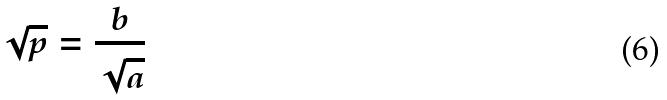<formula> <loc_0><loc_0><loc_500><loc_500>\sqrt { p } = \frac { b } { \sqrt { a } }</formula> 